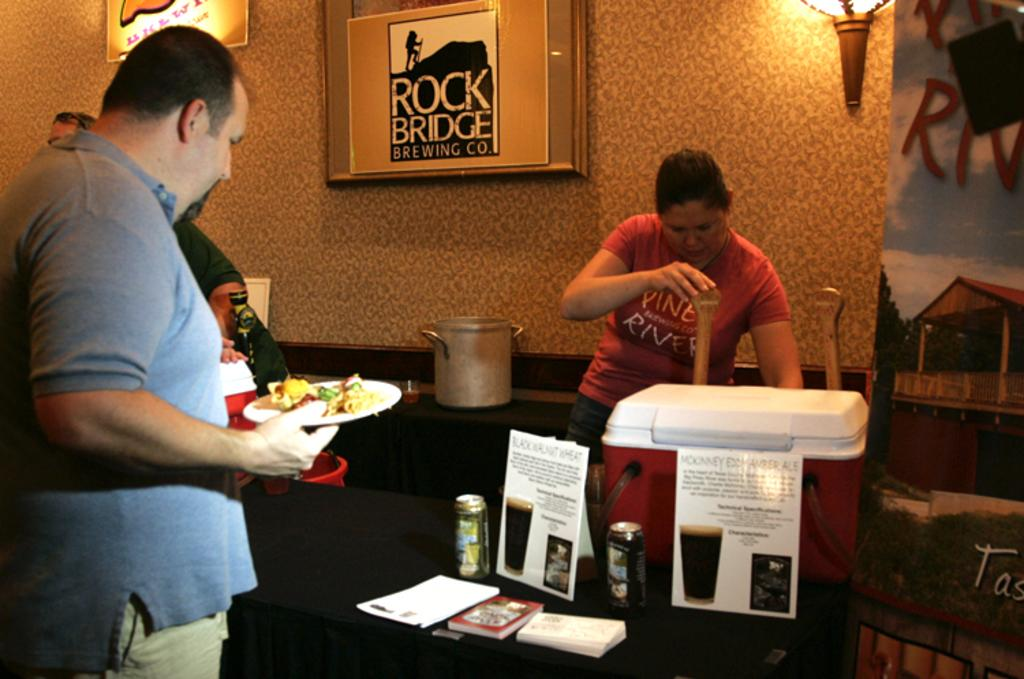<image>
Render a clear and concise summary of the photo. A man in a blue polo shirt stands near a framed poster for Rock Bridge Brewing company. 